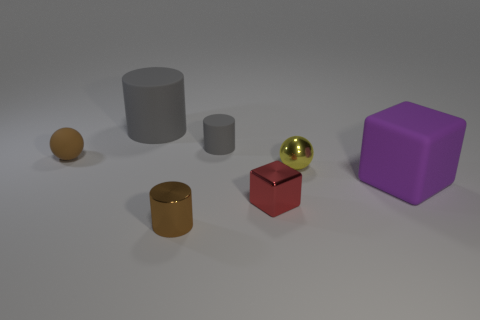How many spheres are either small brown things or brown matte objects?
Ensure brevity in your answer.  1. There is a brown object to the right of the gray rubber thing that is on the left side of the tiny gray thing; how many metallic cubes are right of it?
Your answer should be very brief. 1. What size is the other cylinder that is the same color as the big rubber cylinder?
Provide a short and direct response. Small. Is there a big purple object that has the same material as the red object?
Offer a very short reply. No. Are the large purple object and the yellow thing made of the same material?
Offer a very short reply. No. There is a yellow ball right of the small brown ball; what number of small metal cylinders are in front of it?
Keep it short and to the point. 1. How many red things are either small objects or large things?
Your response must be concise. 1. There is a gray rubber thing that is on the left side of the brown thing in front of the tiny rubber sphere that is to the left of the large purple object; what shape is it?
Offer a terse response. Cylinder. What color is the other matte object that is the same size as the brown rubber thing?
Offer a terse response. Gray. What number of tiny red metal objects are the same shape as the brown rubber thing?
Make the answer very short. 0. 